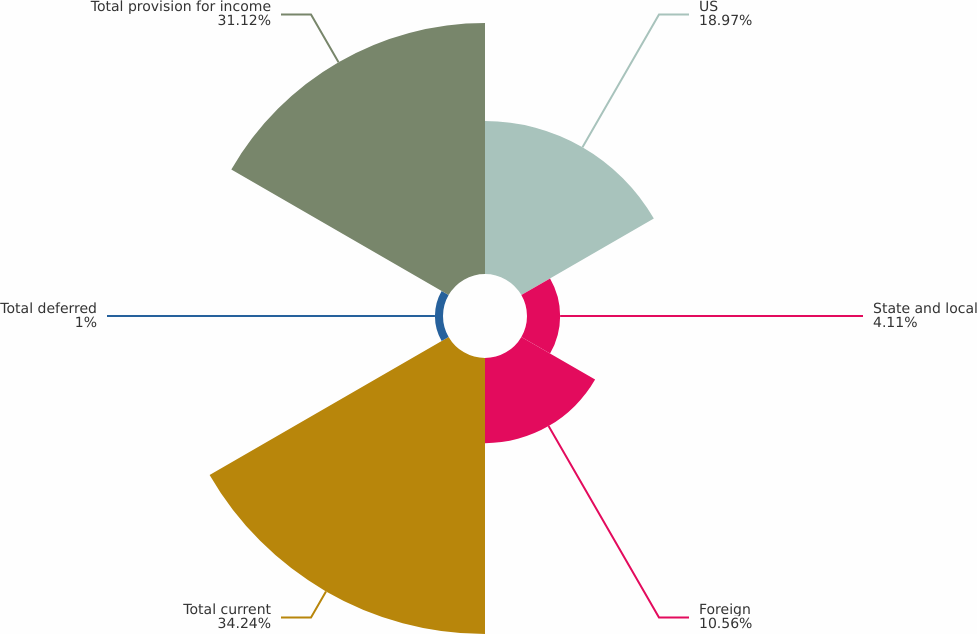Convert chart. <chart><loc_0><loc_0><loc_500><loc_500><pie_chart><fcel>US<fcel>State and local<fcel>Foreign<fcel>Total current<fcel>Total deferred<fcel>Total provision for income<nl><fcel>18.97%<fcel>4.11%<fcel>10.56%<fcel>34.23%<fcel>1.0%<fcel>31.12%<nl></chart> 